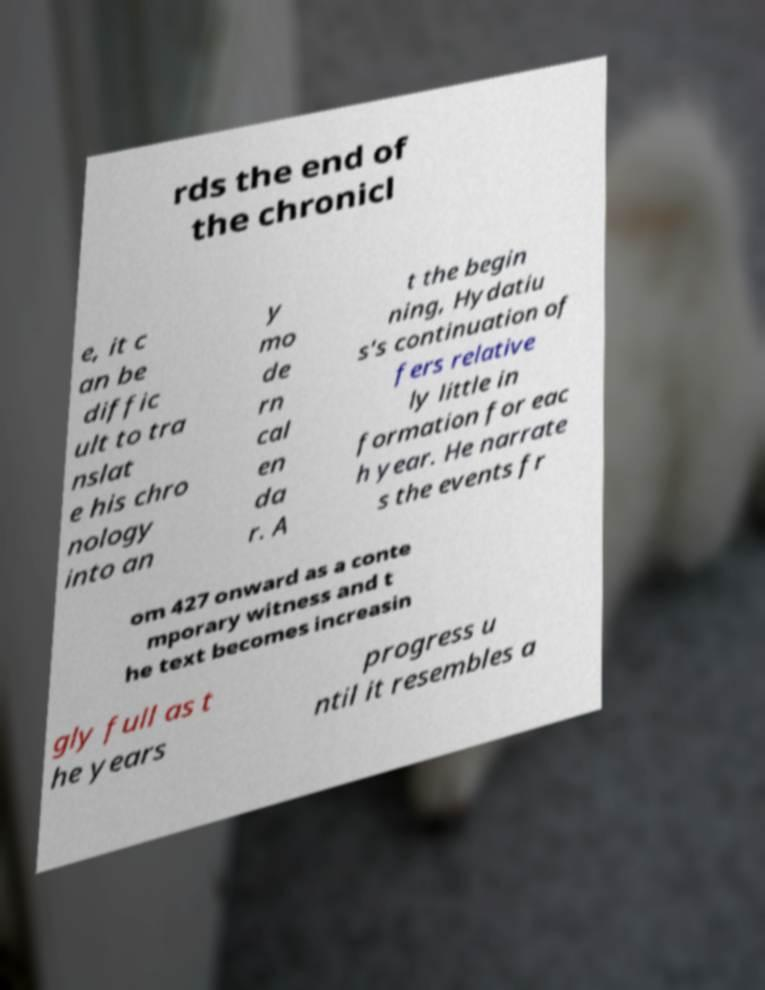Can you read and provide the text displayed in the image?This photo seems to have some interesting text. Can you extract and type it out for me? rds the end of the chronicl e, it c an be diffic ult to tra nslat e his chro nology into an y mo de rn cal en da r. A t the begin ning, Hydatiu s's continuation of fers relative ly little in formation for eac h year. He narrate s the events fr om 427 onward as a conte mporary witness and t he text becomes increasin gly full as t he years progress u ntil it resembles a 